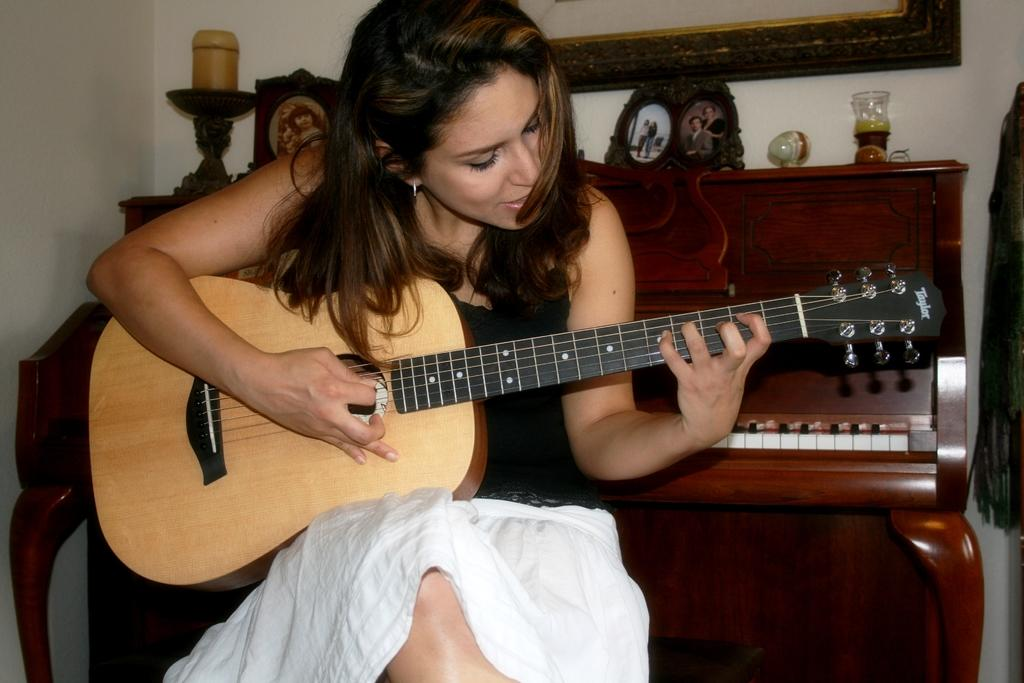Who is the main subject in the image? There is a woman in the image. What is the woman doing in the image? The woman is sitting and playing the guitar. How is the woman holding the guitar? The woman is holding the guitar with her left hand. What is the woman using to play the guitar? The woman is playing the guitar with her right hand. What other musical instrument can be seen in the background of the image? There is a piano in the background of the image. Are there any cobwebs visible on the woman's dress in the image? There is no dress mentioned in the facts, and no cobwebs are visible in the image. 